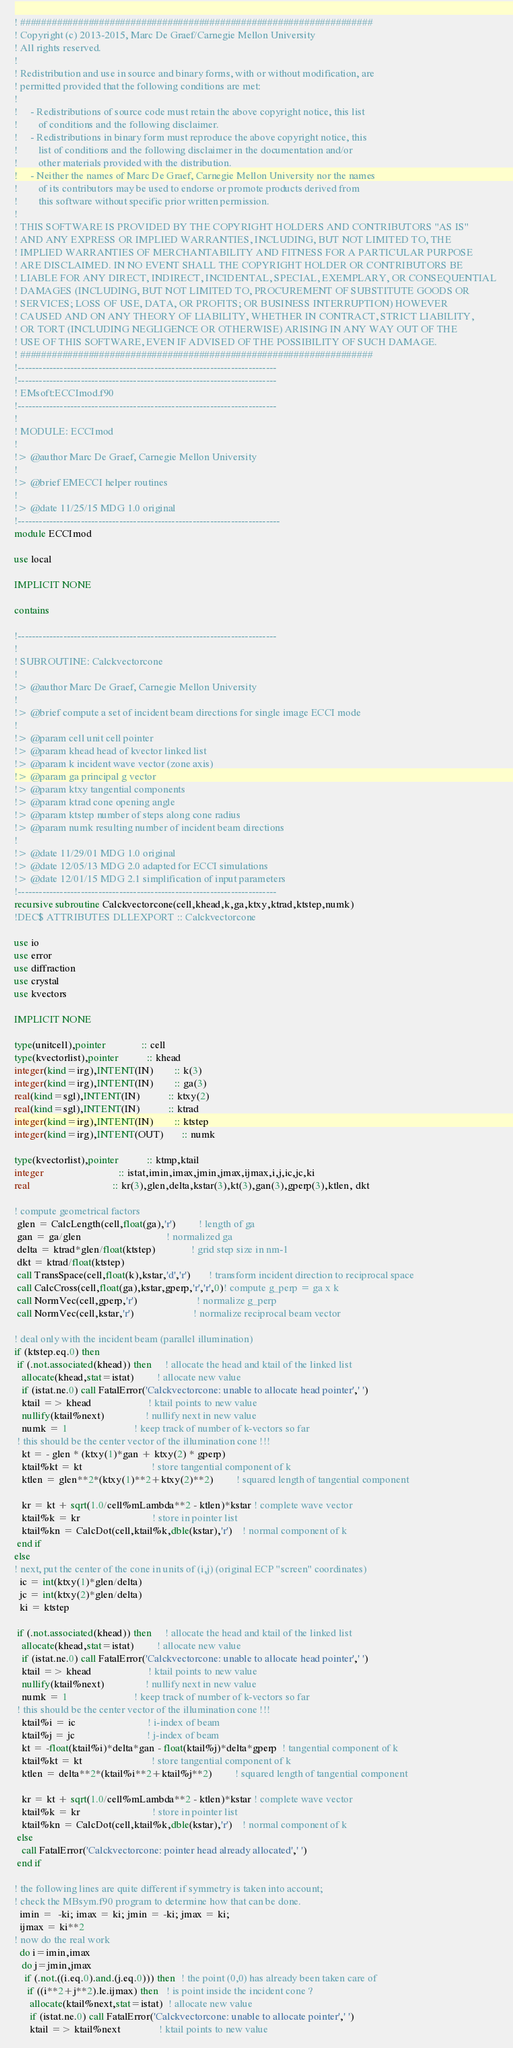<code> <loc_0><loc_0><loc_500><loc_500><_FORTRAN_>! ###################################################################
! Copyright (c) 2013-2015, Marc De Graef/Carnegie Mellon University
! All rights reserved.
!
! Redistribution and use in source and binary forms, with or without modification, are 
! permitted provided that the following conditions are met:
!
!     - Redistributions of source code must retain the above copyright notice, this list 
!        of conditions and the following disclaimer.
!     - Redistributions in binary form must reproduce the above copyright notice, this 
!        list of conditions and the following disclaimer in the documentation and/or 
!        other materials provided with the distribution.
!     - Neither the names of Marc De Graef, Carnegie Mellon University nor the names 
!        of its contributors may be used to endorse or promote products derived from 
!        this software without specific prior written permission.
!
! THIS SOFTWARE IS PROVIDED BY THE COPYRIGHT HOLDERS AND CONTRIBUTORS "AS IS" 
! AND ANY EXPRESS OR IMPLIED WARRANTIES, INCLUDING, BUT NOT LIMITED TO, THE 
! IMPLIED WARRANTIES OF MERCHANTABILITY AND FITNESS FOR A PARTICULAR PURPOSE 
! ARE DISCLAIMED. IN NO EVENT SHALL THE COPYRIGHT HOLDER OR CONTRIBUTORS BE 
! LIABLE FOR ANY DIRECT, INDIRECT, INCIDENTAL, SPECIAL, EXEMPLARY, OR CONSEQUENTIAL 
! DAMAGES (INCLUDING, BUT NOT LIMITED TO, PROCUREMENT OF SUBSTITUTE GOODS OR 
! SERVICES; LOSS OF USE, DATA, OR PROFITS; OR BUSINESS INTERRUPTION) HOWEVER 
! CAUSED AND ON ANY THEORY OF LIABILITY, WHETHER IN CONTRACT, STRICT LIABILITY, 
! OR TORT (INCLUDING NEGLIGENCE OR OTHERWISE) ARISING IN ANY WAY OUT OF THE 
! USE OF THIS SOFTWARE, EVEN IF ADVISED OF THE POSSIBILITY OF SUCH DAMAGE.
! ###################################################################
!--------------------------------------------------------------------------
!--------------------------------------------------------------------------
! EMsoft:ECCImod.f90
!--------------------------------------------------------------------------
!
! MODULE: ECCImod
!
!> @author Marc De Graef, Carnegie Mellon University
!
!> @brief EMECCI helper routines
!
!> @date 11/25/15 MDG 1.0 original
!---------------------------------------------------------------------------
module ECCImod

use local

IMPLICIT NONE

contains

!--------------------------------------------------------------------------
!
! SUBROUTINE: Calckvectorcone
!
!> @author Marc De Graef, Carnegie Mellon University
!
!> @brief compute a set of incident beam directions for single image ECCI mode
!
!> @param cell unit cell pointer
!> @param khead head of kvector linked list
!> @param k incident wave vector (zone axis)
!> @param ga principal g vector
!> @param ktxy tangential components
!> @param ktrad cone opening angle
!> @param ktstep number of steps along cone radius
!> @param numk resulting number of incident beam directions
!
!> @date 11/29/01 MDG 1.0 original
!> @date 12/05/13 MDG 2.0 adapted for ECCI simulations 
!> @date 12/01/15 MDG 2.1 simplification of input parameters
!--------------------------------------------------------------------------
recursive subroutine Calckvectorcone(cell,khead,k,ga,ktxy,ktrad,ktstep,numk)
!DEC$ ATTRIBUTES DLLEXPORT :: Calckvectorcone

use io
use error
use diffraction
use crystal
use kvectors

IMPLICIT NONE

type(unitcell),pointer              :: cell
type(kvectorlist),pointer           :: khead
integer(kind=irg),INTENT(IN)        :: k(3)
integer(kind=irg),INTENT(IN)        :: ga(3)
real(kind=sgl),INTENT(IN)           :: ktxy(2)
real(kind=sgl),INTENT(IN)           :: ktrad
integer(kind=irg),INTENT(IN)        :: ktstep
integer(kind=irg),INTENT(OUT)       :: numk

type(kvectorlist),pointer           :: ktmp,ktail
integer                             :: istat,imin,imax,jmin,jmax,ijmax,i,j,ic,jc,ki
real                                :: kr(3),glen,delta,kstar(3),kt(3),gan(3),gperp(3),ktlen, dkt

! compute geometrical factors 
 glen = CalcLength(cell,float(ga),'r')         ! length of ga
 gan = ga/glen                                 ! normalized ga
 delta = ktrad*glen/float(ktstep)              ! grid step size in nm-1 
 dkt = ktrad/float(ktstep)
 call TransSpace(cell,float(k),kstar,'d','r')       ! transform incident direction to reciprocal space
 call CalcCross(cell,float(ga),kstar,gperp,'r','r',0)! compute g_perp = ga x k
 call NormVec(cell,gperp,'r')                       ! normalize g_perp
 call NormVec(cell,kstar,'r')                       ! normalize reciprocal beam vector

! deal only with the incident beam (parallel illumination)
if (ktstep.eq.0) then
 if (.not.associated(khead)) then     ! allocate the head and ktail of the linked list
   allocate(khead,stat=istat)         ! allocate new value
   if (istat.ne.0) call FatalError('Calckvectorcone: unable to allocate head pointer',' ')
   ktail => khead                      ! ktail points to new value
   nullify(ktail%next)                ! nullify next in new value
   numk = 1                          ! keep track of number of k-vectors so far
 ! this should be the center vector of the illumination cone !!!
   kt = - glen * (ktxy(1)*gan + ktxy(2) * gperp)
   ktail%kt = kt                           ! store tangential component of k
   ktlen = glen**2*(ktxy(1)**2+ktxy(2)**2)         ! squared length of tangential component
   
   kr = kt + sqrt(1.0/cell%mLambda**2 - ktlen)*kstar ! complete wave vector
   ktail%k = kr                            ! store in pointer list
   ktail%kn = CalcDot(cell,ktail%k,dble(kstar),'r')    ! normal component of k
 end if
else
! next, put the center of the cone in units of (i,j) (original ECP "screen" coordinates)
  ic = int(ktxy(1)*glen/delta)
  jc = int(ktxy(2)*glen/delta)
  ki = ktstep

 if (.not.associated(khead)) then     ! allocate the head and ktail of the linked list
   allocate(khead,stat=istat)         ! allocate new value
   if (istat.ne.0) call FatalError('Calckvectorcone: unable to allocate head pointer',' ')
   ktail => khead                      ! ktail points to new value
   nullify(ktail%next)                ! nullify next in new value
   numk = 1                          ! keep track of number of k-vectors so far
 ! this should be the center vector of the illumination cone !!!
   ktail%i = ic                            ! i-index of beam
   ktail%j = jc                            ! j-index of beam
   kt = -float(ktail%i)*delta*gan - float(ktail%j)*delta*gperp  ! tangential component of k
   ktail%kt = kt                           ! store tangential component of k
   ktlen = delta**2*(ktail%i**2+ktail%j**2)         ! squared length of tangential component

   kr = kt + sqrt(1.0/cell%mLambda**2 - ktlen)*kstar ! complete wave vector
   ktail%k = kr                            ! store in pointer list
   ktail%kn = CalcDot(cell,ktail%k,dble(kstar),'r')    ! normal component of k
 else
   call FatalError('Calckvectorcone: pointer head already allocated',' ')
 end if

! the following lines are quite different if symmetry is taken into account;
! check the MBsym.f90 program to determine how that can be done.
  imin =  -ki; imax = ki; jmin = -ki; jmax = ki; 
  ijmax = ki**2
! now do the real work
  do i=imin,imax
   do j=jmin,jmax
    if (.not.((i.eq.0).and.(j.eq.0))) then  ! the point (0,0) has already been taken care of
     if ((i**2+j**2).le.ijmax) then   ! is point inside the incident cone ?
      allocate(ktail%next,stat=istat)  ! allocate new value
      if (istat.ne.0) call FatalError('Calckvectorcone: unable to allocate pointer',' ')
      ktail => ktail%next               ! ktail points to new value</code> 